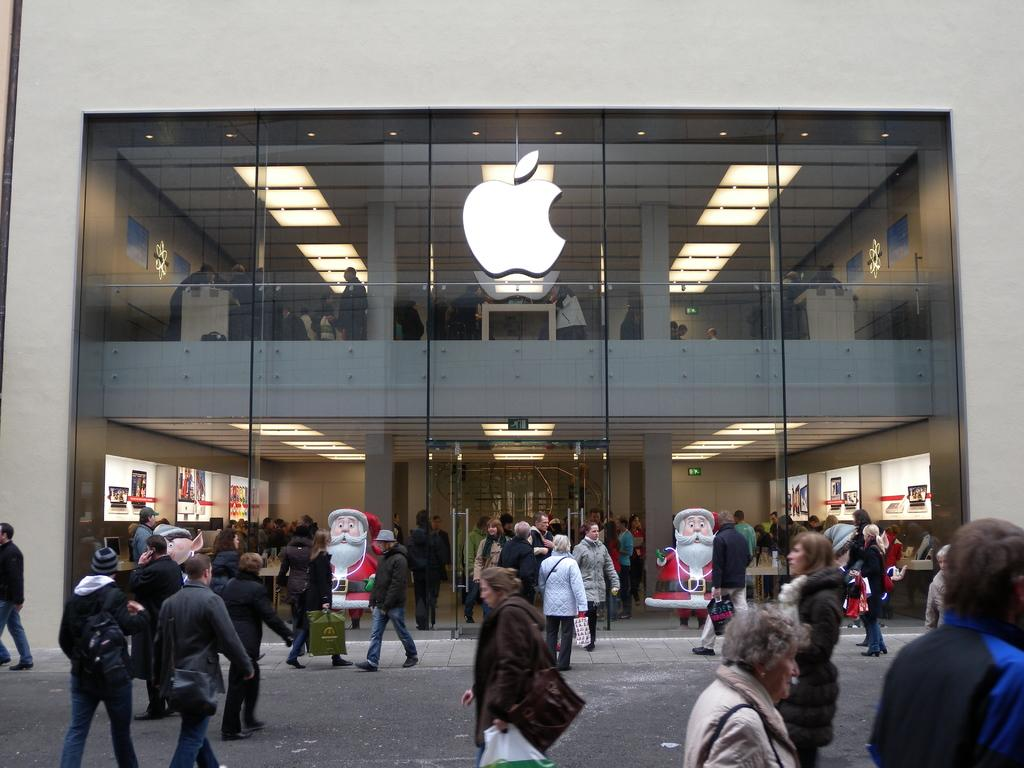What logo can be seen on the glass wall in the image? There is an apple logo on a glass wall in the image. What can be seen through the glass wall? People and lights are visible through the glass wall. What is the location of the people in the image? There are people in front of the glass building. What decorative elements are present in front of the glass building? There are statues in front of the glass building. How does the egg move around in the image? There is no egg present in the image, so it cannot move around. 